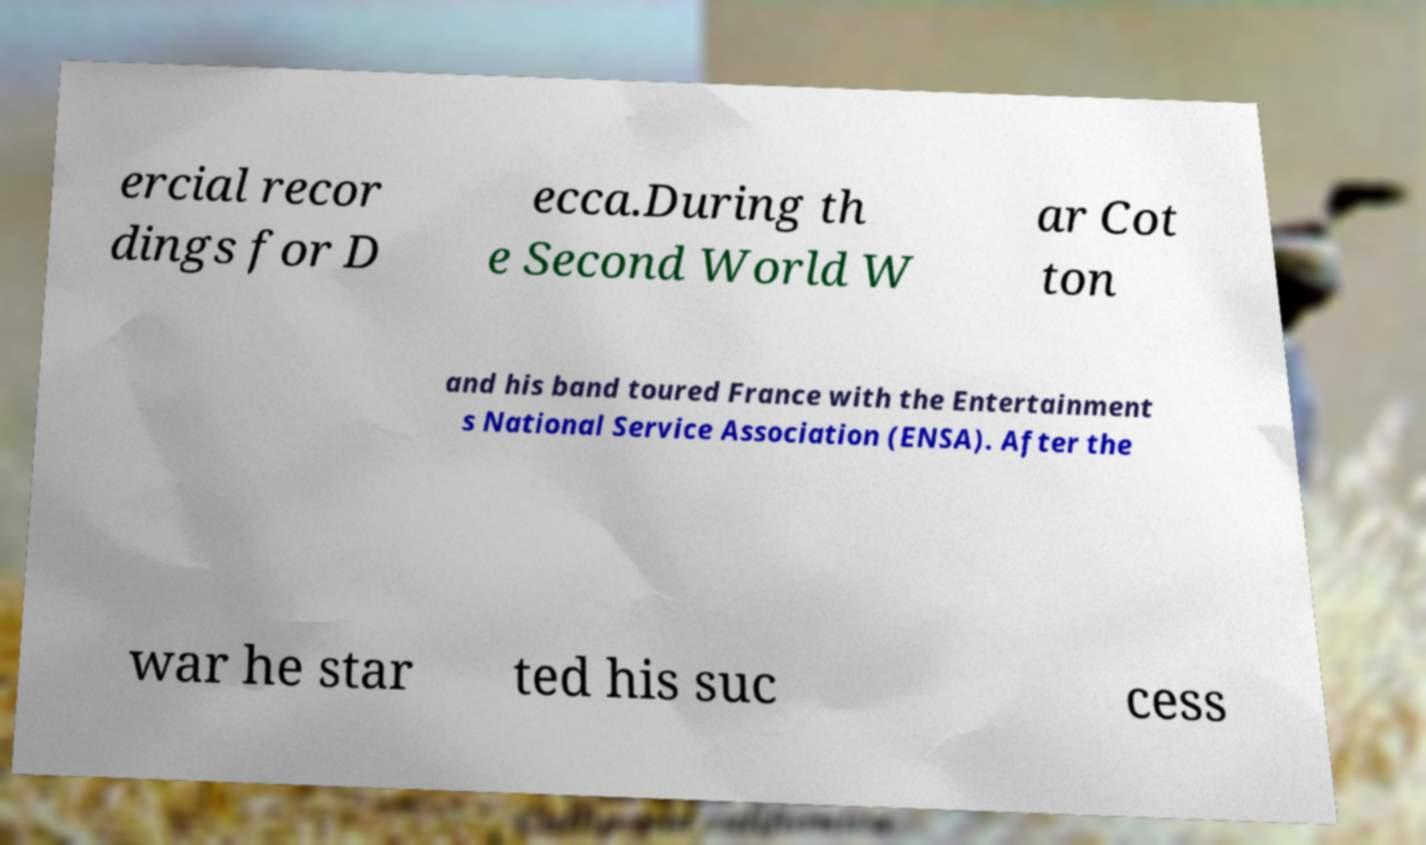I need the written content from this picture converted into text. Can you do that? ercial recor dings for D ecca.During th e Second World W ar Cot ton and his band toured France with the Entertainment s National Service Association (ENSA). After the war he star ted his suc cess 